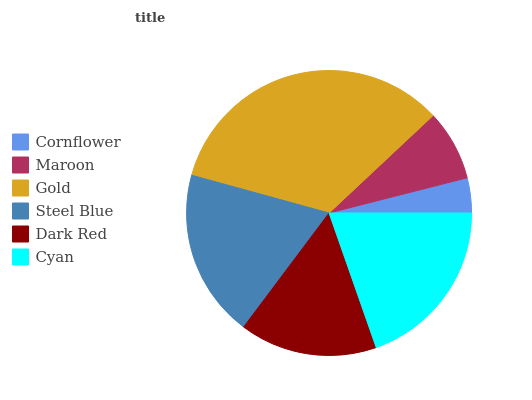Is Cornflower the minimum?
Answer yes or no. Yes. Is Gold the maximum?
Answer yes or no. Yes. Is Maroon the minimum?
Answer yes or no. No. Is Maroon the maximum?
Answer yes or no. No. Is Maroon greater than Cornflower?
Answer yes or no. Yes. Is Cornflower less than Maroon?
Answer yes or no. Yes. Is Cornflower greater than Maroon?
Answer yes or no. No. Is Maroon less than Cornflower?
Answer yes or no. No. Is Steel Blue the high median?
Answer yes or no. Yes. Is Dark Red the low median?
Answer yes or no. Yes. Is Dark Red the high median?
Answer yes or no. No. Is Gold the low median?
Answer yes or no. No. 